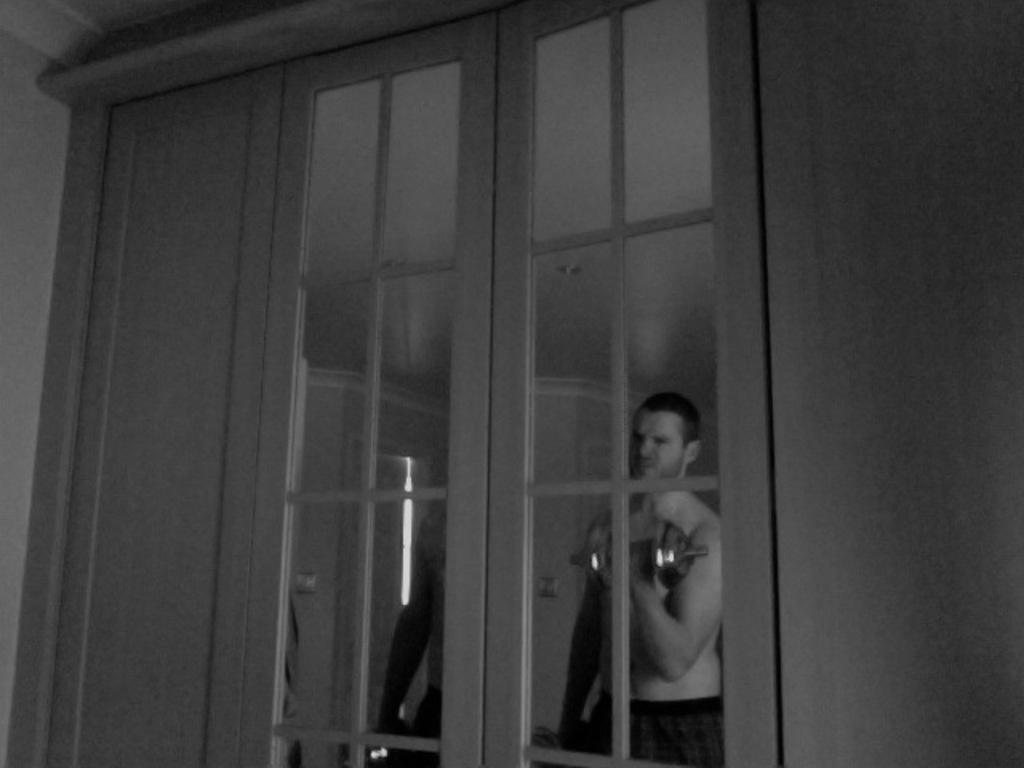Describe this image in one or two sentences. In this image there is a door as we can see in middle of this image. There is one person standing at right side of this image is holding a dumbbell and there is one another person is at left side of this image. 